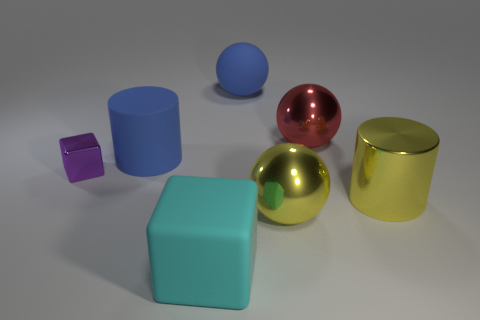Add 3 small purple metallic objects. How many objects exist? 10 Subtract all cylinders. How many objects are left? 5 Add 2 blue rubber cylinders. How many blue rubber cylinders exist? 3 Subtract 0 red blocks. How many objects are left? 7 Subtract all big cyan metal balls. Subtract all tiny shiny blocks. How many objects are left? 6 Add 4 purple things. How many purple things are left? 5 